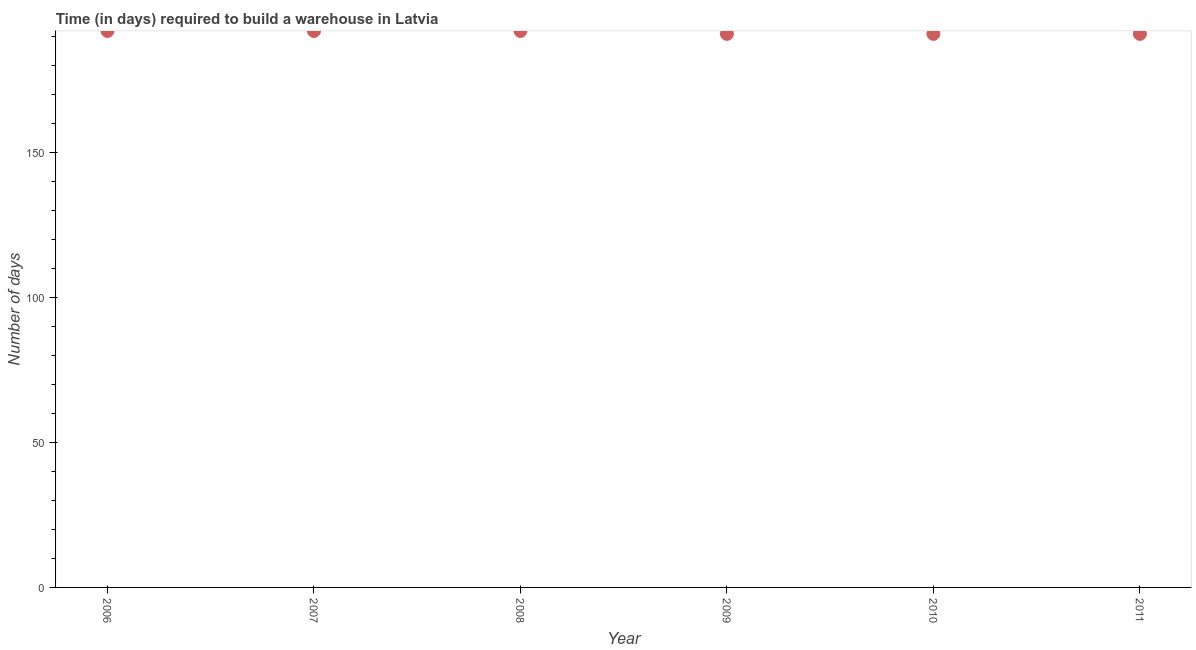What is the time required to build a warehouse in 2011?
Keep it short and to the point. 191. Across all years, what is the maximum time required to build a warehouse?
Offer a terse response. 192. Across all years, what is the minimum time required to build a warehouse?
Your answer should be very brief. 191. In which year was the time required to build a warehouse maximum?
Make the answer very short. 2006. In which year was the time required to build a warehouse minimum?
Offer a terse response. 2009. What is the sum of the time required to build a warehouse?
Ensure brevity in your answer.  1149. What is the average time required to build a warehouse per year?
Make the answer very short. 191.5. What is the median time required to build a warehouse?
Your answer should be very brief. 191.5. Do a majority of the years between 2007 and 2008 (inclusive) have time required to build a warehouse greater than 140 days?
Give a very brief answer. Yes. What is the ratio of the time required to build a warehouse in 2007 to that in 2009?
Your answer should be compact. 1.01. Is the time required to build a warehouse in 2008 less than that in 2010?
Give a very brief answer. No. Is the difference between the time required to build a warehouse in 2008 and 2011 greater than the difference between any two years?
Provide a succinct answer. Yes. What is the difference between the highest and the second highest time required to build a warehouse?
Your answer should be compact. 0. Is the sum of the time required to build a warehouse in 2006 and 2009 greater than the maximum time required to build a warehouse across all years?
Ensure brevity in your answer.  Yes. What is the difference between the highest and the lowest time required to build a warehouse?
Your response must be concise. 1. Does the time required to build a warehouse monotonically increase over the years?
Provide a succinct answer. No. How many years are there in the graph?
Your answer should be very brief. 6. What is the difference between two consecutive major ticks on the Y-axis?
Your response must be concise. 50. Are the values on the major ticks of Y-axis written in scientific E-notation?
Provide a short and direct response. No. Does the graph contain grids?
Give a very brief answer. No. What is the title of the graph?
Provide a short and direct response. Time (in days) required to build a warehouse in Latvia. What is the label or title of the X-axis?
Your answer should be compact. Year. What is the label or title of the Y-axis?
Keep it short and to the point. Number of days. What is the Number of days in 2006?
Provide a succinct answer. 192. What is the Number of days in 2007?
Ensure brevity in your answer.  192. What is the Number of days in 2008?
Keep it short and to the point. 192. What is the Number of days in 2009?
Ensure brevity in your answer.  191. What is the Number of days in 2010?
Offer a very short reply. 191. What is the Number of days in 2011?
Provide a succinct answer. 191. What is the difference between the Number of days in 2006 and 2007?
Keep it short and to the point. 0. What is the difference between the Number of days in 2006 and 2009?
Keep it short and to the point. 1. What is the difference between the Number of days in 2006 and 2010?
Provide a short and direct response. 1. What is the difference between the Number of days in 2006 and 2011?
Make the answer very short. 1. What is the difference between the Number of days in 2007 and 2009?
Your answer should be compact. 1. What is the difference between the Number of days in 2008 and 2010?
Make the answer very short. 1. What is the difference between the Number of days in 2008 and 2011?
Make the answer very short. 1. What is the difference between the Number of days in 2009 and 2011?
Your answer should be compact. 0. What is the ratio of the Number of days in 2006 to that in 2010?
Ensure brevity in your answer.  1. What is the ratio of the Number of days in 2006 to that in 2011?
Make the answer very short. 1. What is the ratio of the Number of days in 2007 to that in 2010?
Give a very brief answer. 1. What is the ratio of the Number of days in 2008 to that in 2010?
Make the answer very short. 1. What is the ratio of the Number of days in 2009 to that in 2011?
Keep it short and to the point. 1. What is the ratio of the Number of days in 2010 to that in 2011?
Your response must be concise. 1. 